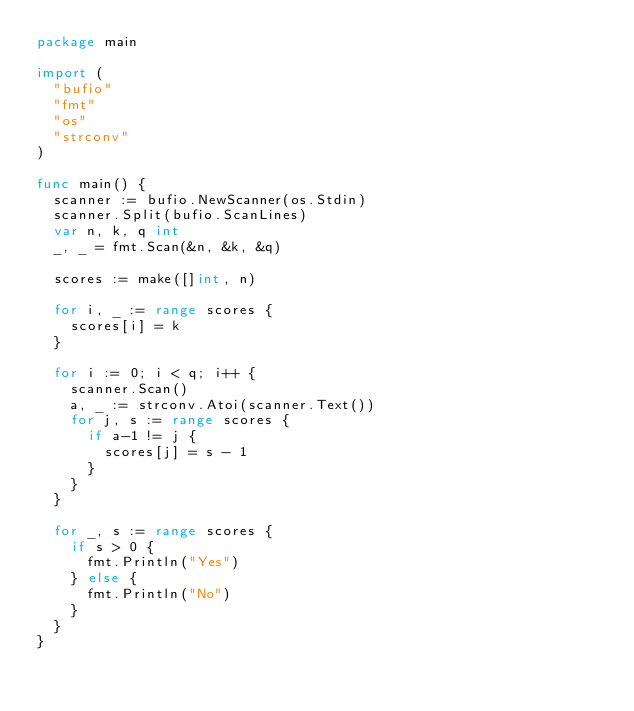Convert code to text. <code><loc_0><loc_0><loc_500><loc_500><_Go_>package main

import (
	"bufio"
	"fmt"
	"os"
	"strconv"
)

func main() {
	scanner := bufio.NewScanner(os.Stdin)
	scanner.Split(bufio.ScanLines)
	var n, k, q int
	_, _ = fmt.Scan(&n, &k, &q)
	
	scores := make([]int, n)
	
	for i, _ := range scores {
		scores[i] = k
	}
	
	for i := 0; i < q; i++ {
		scanner.Scan()
		a, _ := strconv.Atoi(scanner.Text())
		for j, s := range scores {
			if a-1 != j {
				scores[j] = s - 1
			}
		}
	}
	
	for _, s := range scores {
		if s > 0 {
			fmt.Println("Yes")
		} else {
			fmt.Println("No")
		}
	}
}
</code> 